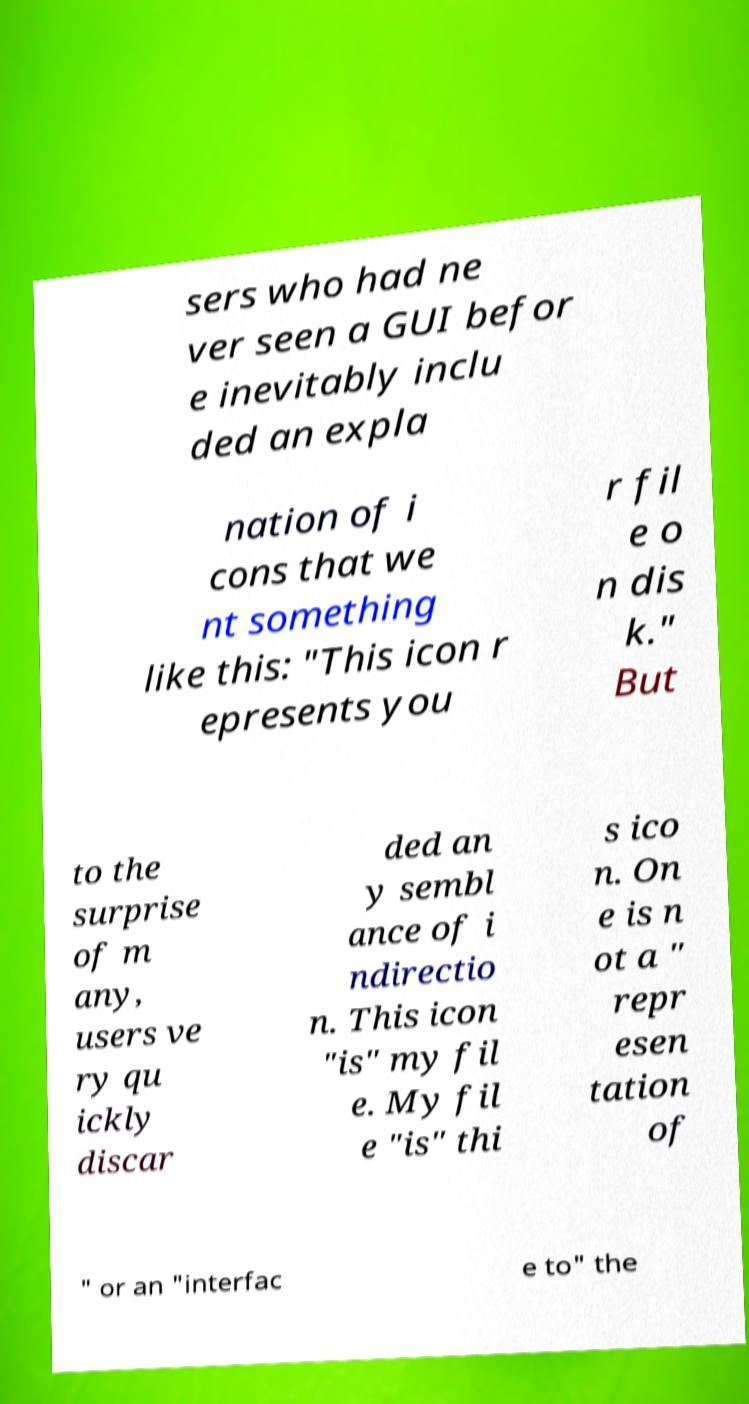There's text embedded in this image that I need extracted. Can you transcribe it verbatim? sers who had ne ver seen a GUI befor e inevitably inclu ded an expla nation of i cons that we nt something like this: "This icon r epresents you r fil e o n dis k." But to the surprise of m any, users ve ry qu ickly discar ded an y sembl ance of i ndirectio n. This icon "is" my fil e. My fil e "is" thi s ico n. On e is n ot a " repr esen tation of " or an "interfac e to" the 